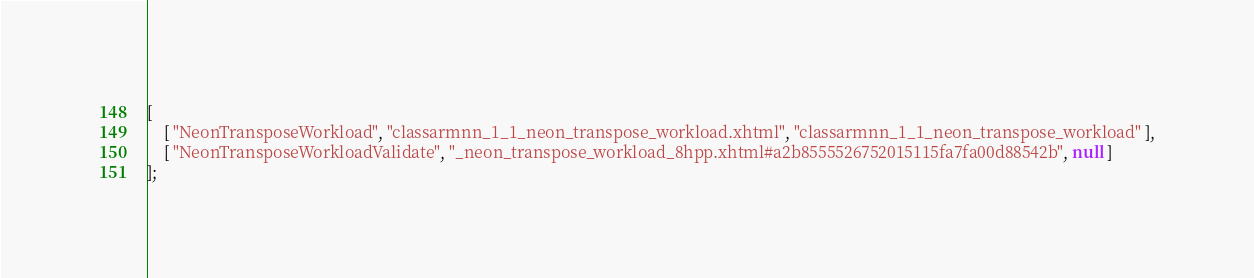Convert code to text. <code><loc_0><loc_0><loc_500><loc_500><_JavaScript_>[
    [ "NeonTransposeWorkload", "classarmnn_1_1_neon_transpose_workload.xhtml", "classarmnn_1_1_neon_transpose_workload" ],
    [ "NeonTransposeWorkloadValidate", "_neon_transpose_workload_8hpp.xhtml#a2b8555526752015115fa7fa00d88542b", null ]
];</code> 